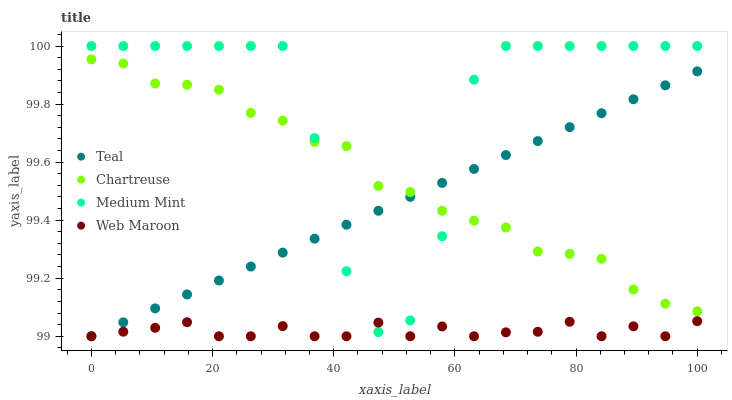Does Web Maroon have the minimum area under the curve?
Answer yes or no. Yes. Does Medium Mint have the maximum area under the curve?
Answer yes or no. Yes. Does Chartreuse have the minimum area under the curve?
Answer yes or no. No. Does Chartreuse have the maximum area under the curve?
Answer yes or no. No. Is Teal the smoothest?
Answer yes or no. Yes. Is Medium Mint the roughest?
Answer yes or no. Yes. Is Chartreuse the smoothest?
Answer yes or no. No. Is Chartreuse the roughest?
Answer yes or no. No. Does Web Maroon have the lowest value?
Answer yes or no. Yes. Does Chartreuse have the lowest value?
Answer yes or no. No. Does Medium Mint have the highest value?
Answer yes or no. Yes. Does Chartreuse have the highest value?
Answer yes or no. No. Is Web Maroon less than Chartreuse?
Answer yes or no. Yes. Is Chartreuse greater than Web Maroon?
Answer yes or no. Yes. Does Chartreuse intersect Teal?
Answer yes or no. Yes. Is Chartreuse less than Teal?
Answer yes or no. No. Is Chartreuse greater than Teal?
Answer yes or no. No. Does Web Maroon intersect Chartreuse?
Answer yes or no. No. 